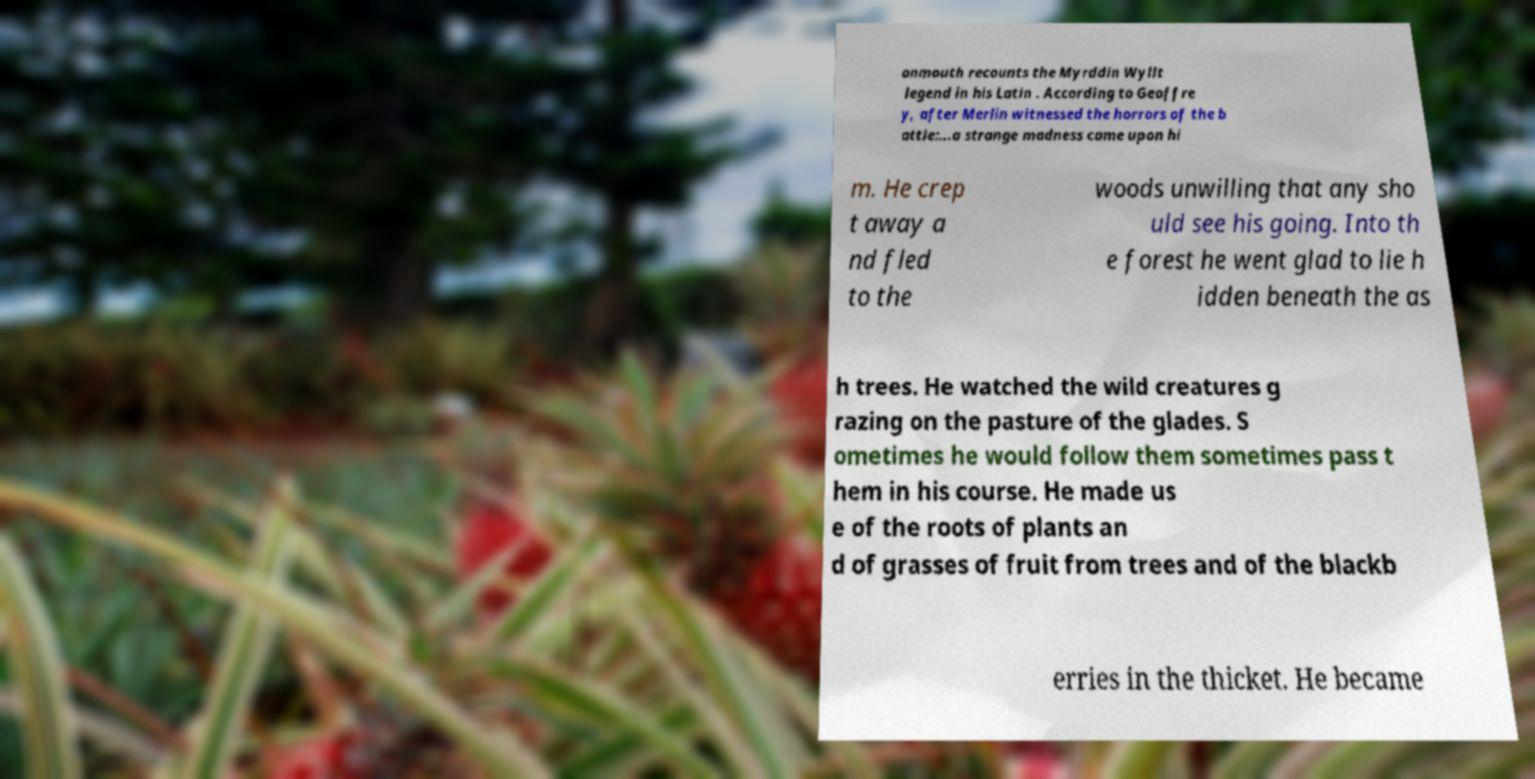Could you extract and type out the text from this image? onmouth recounts the Myrddin Wyllt legend in his Latin . According to Geoffre y, after Merlin witnessed the horrors of the b attle:...a strange madness came upon hi m. He crep t away a nd fled to the woods unwilling that any sho uld see his going. Into th e forest he went glad to lie h idden beneath the as h trees. He watched the wild creatures g razing on the pasture of the glades. S ometimes he would follow them sometimes pass t hem in his course. He made us e of the roots of plants an d of grasses of fruit from trees and of the blackb erries in the thicket. He became 